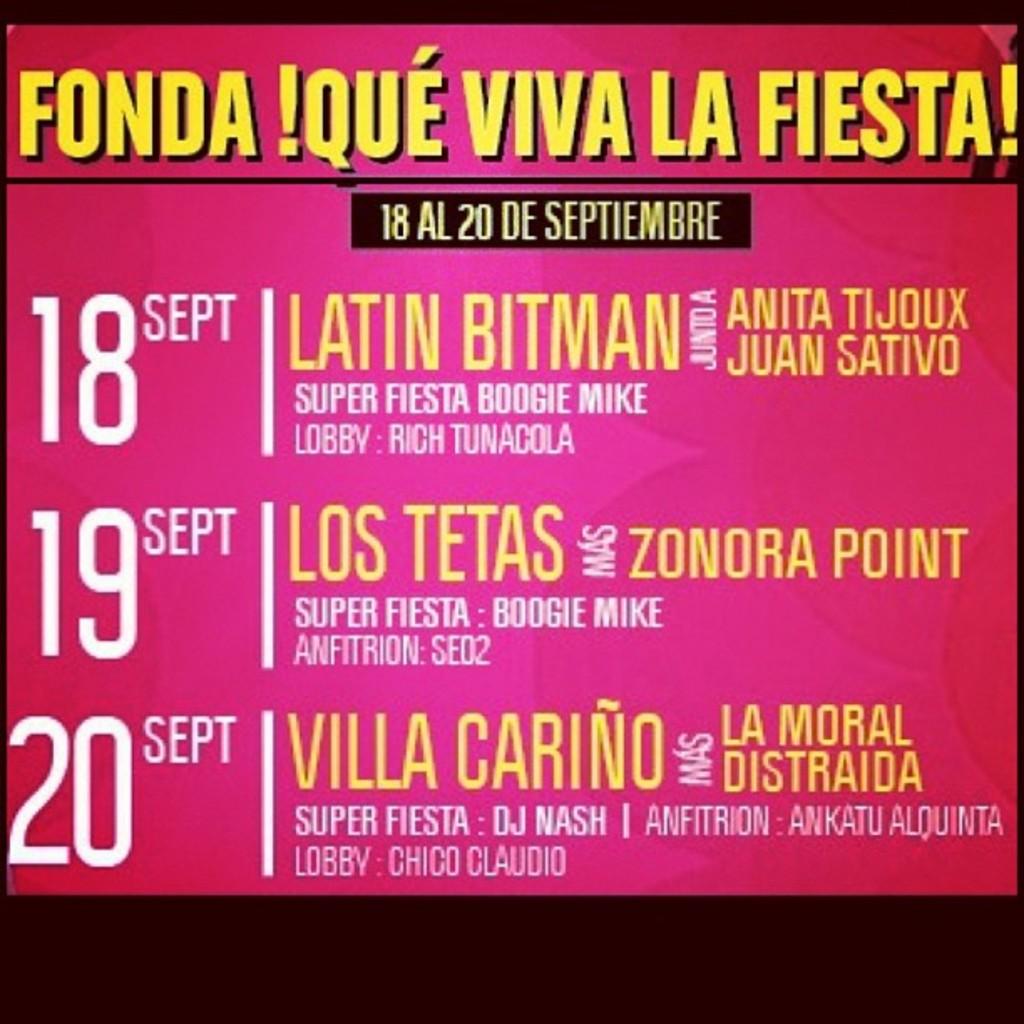On what day is los tetas performing?
Your answer should be compact. September 19. 